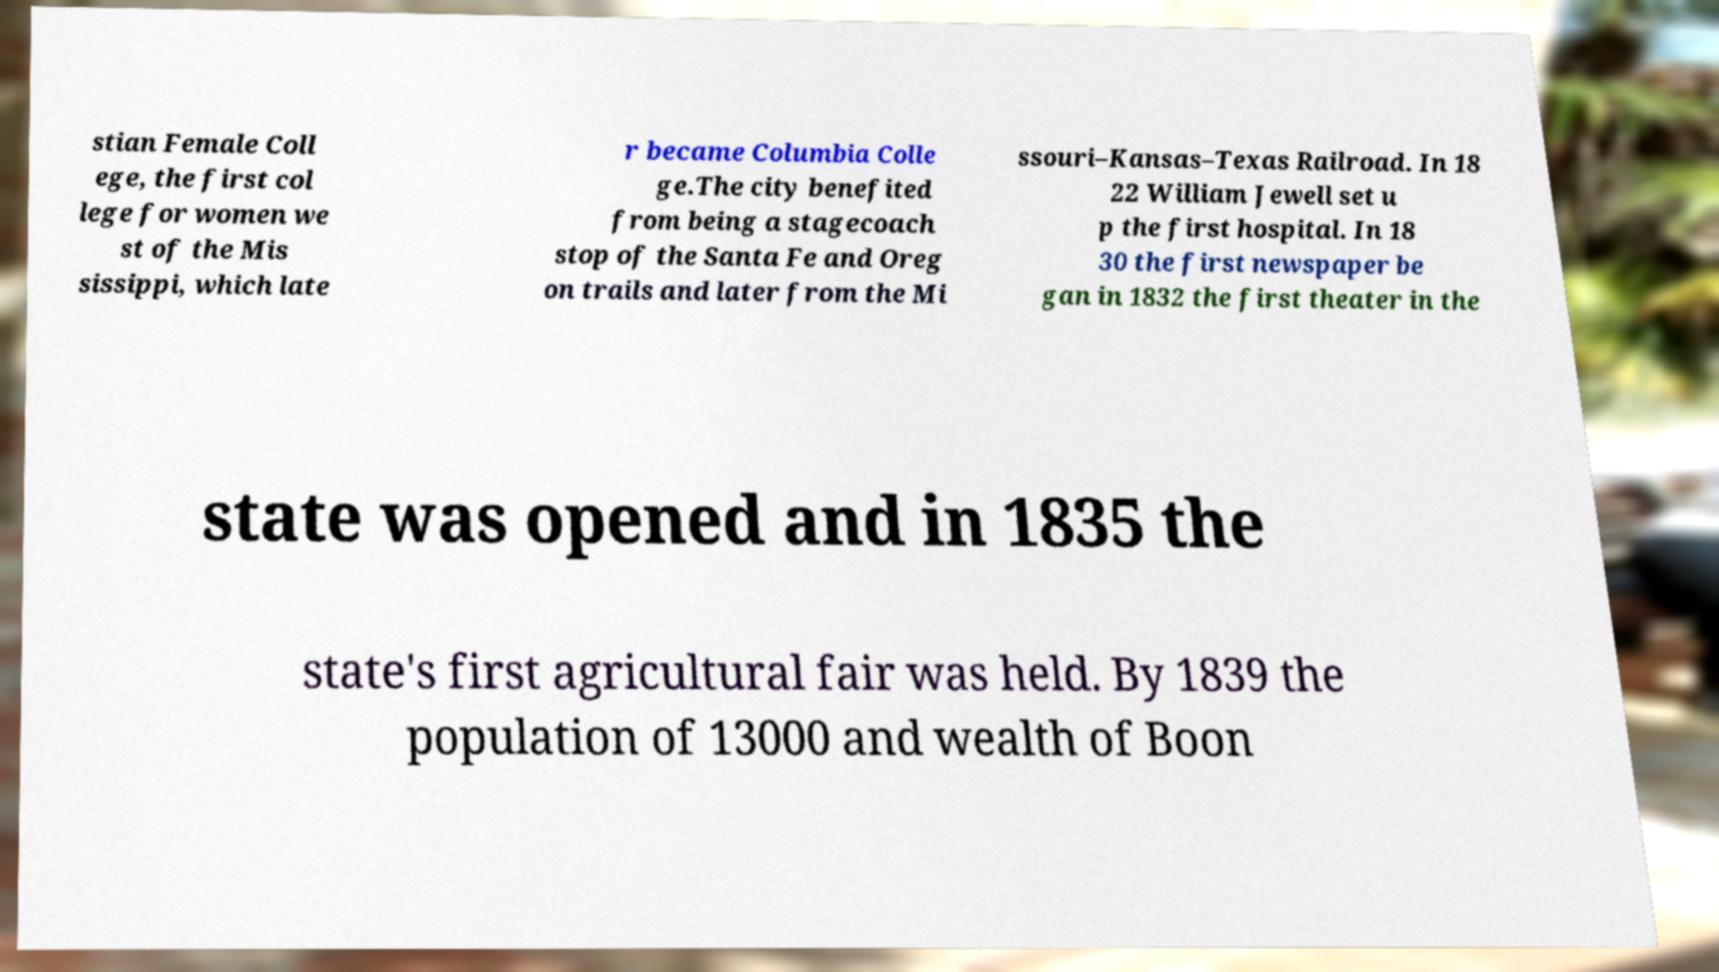Please read and relay the text visible in this image. What does it say? stian Female Coll ege, the first col lege for women we st of the Mis sissippi, which late r became Columbia Colle ge.The city benefited from being a stagecoach stop of the Santa Fe and Oreg on trails and later from the Mi ssouri–Kansas–Texas Railroad. In 18 22 William Jewell set u p the first hospital. In 18 30 the first newspaper be gan in 1832 the first theater in the state was opened and in 1835 the state's first agricultural fair was held. By 1839 the population of 13000 and wealth of Boon 